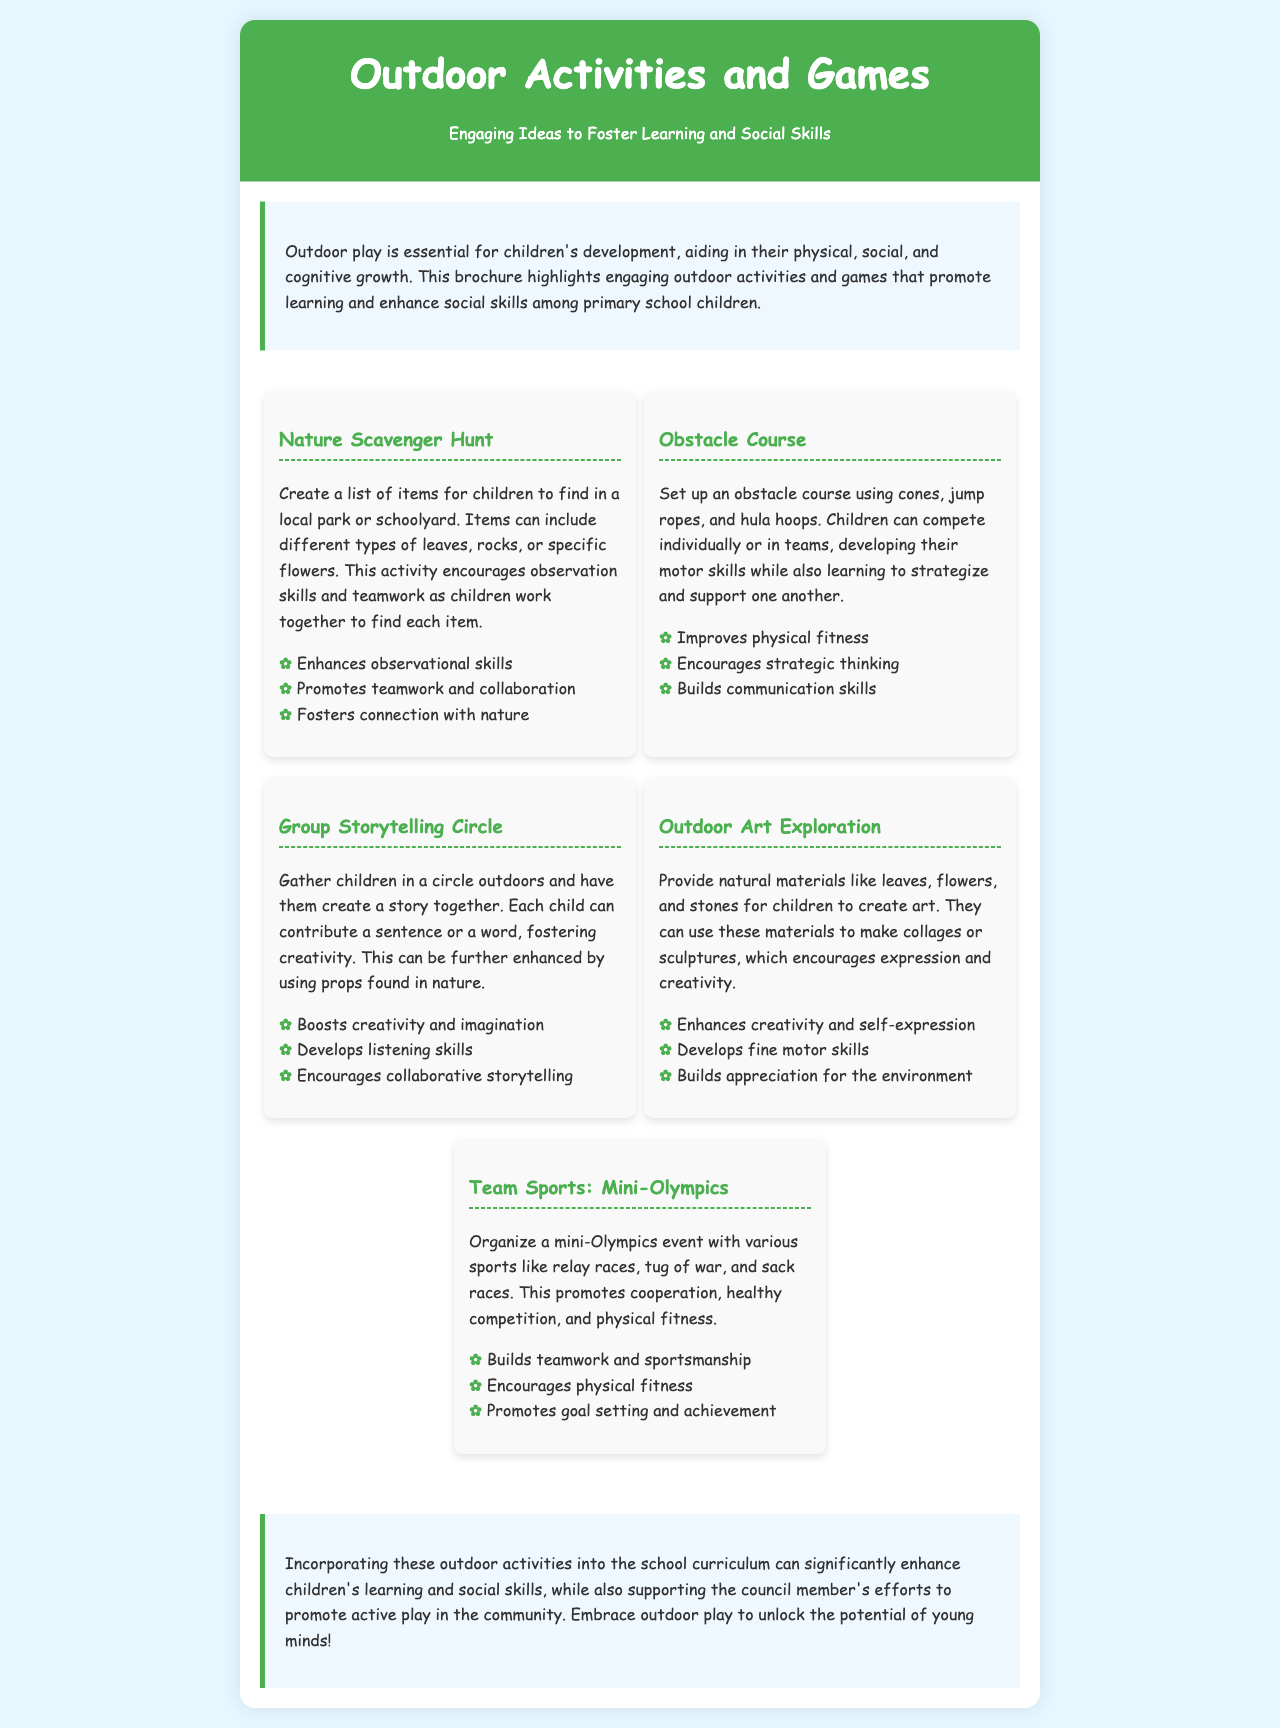What is the title of the brochure? The title is stated at the top of the brochure, emphasizing the theme.
Answer: Outdoor Activities and Games What kind of skills does outdoor play help develop in children? The introduction describes the various types of development that outdoor play aids in.
Answer: Physical, social, and cognitive Which activity involves finding items in nature? The document lists various activities, with one specifically focused on searching for items in a natural environment.
Answer: Nature Scavenger Hunt What is one benefit of the Obstacle Course activity? Each activity includes a list of benefits, highlighting what children gain from participating.
Answer: Improves physical fitness How many activities are listed in the brochure? The document includes a section detailing various activities.
Answer: Five What is one way to enhance the Group Storytelling Circle? The activity descriptions include suggestions for enhancement or variation during implementation.
Answer: Using props found in nature What is the purpose of organizing a Mini-Olympics? The document outlines the main goals behind the sports event in terms of children’s development.
Answer: Promotes cooperation, healthy competition, and physical fitness What does the conclusion emphasize about outdoor activities? The conclusion summarizes the overall importance of integrating the activities discussed in the brochure.
Answer: Enhance children's learning and social skills 